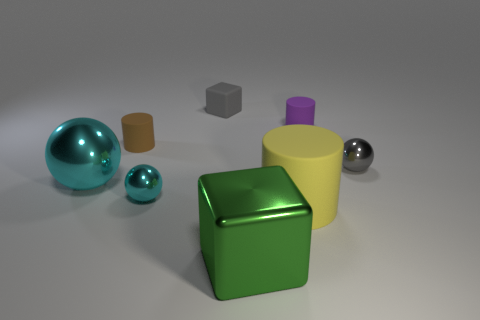Subtract all brown matte cylinders. How many cylinders are left? 2 Subtract all blue cylinders. How many cyan balls are left? 2 Add 1 small gray shiny spheres. How many objects exist? 9 Subtract all balls. How many objects are left? 5 Subtract 1 green cubes. How many objects are left? 7 Subtract all small blocks. Subtract all yellow metallic cylinders. How many objects are left? 7 Add 5 big blocks. How many big blocks are left? 6 Add 4 big blue cubes. How many big blue cubes exist? 4 